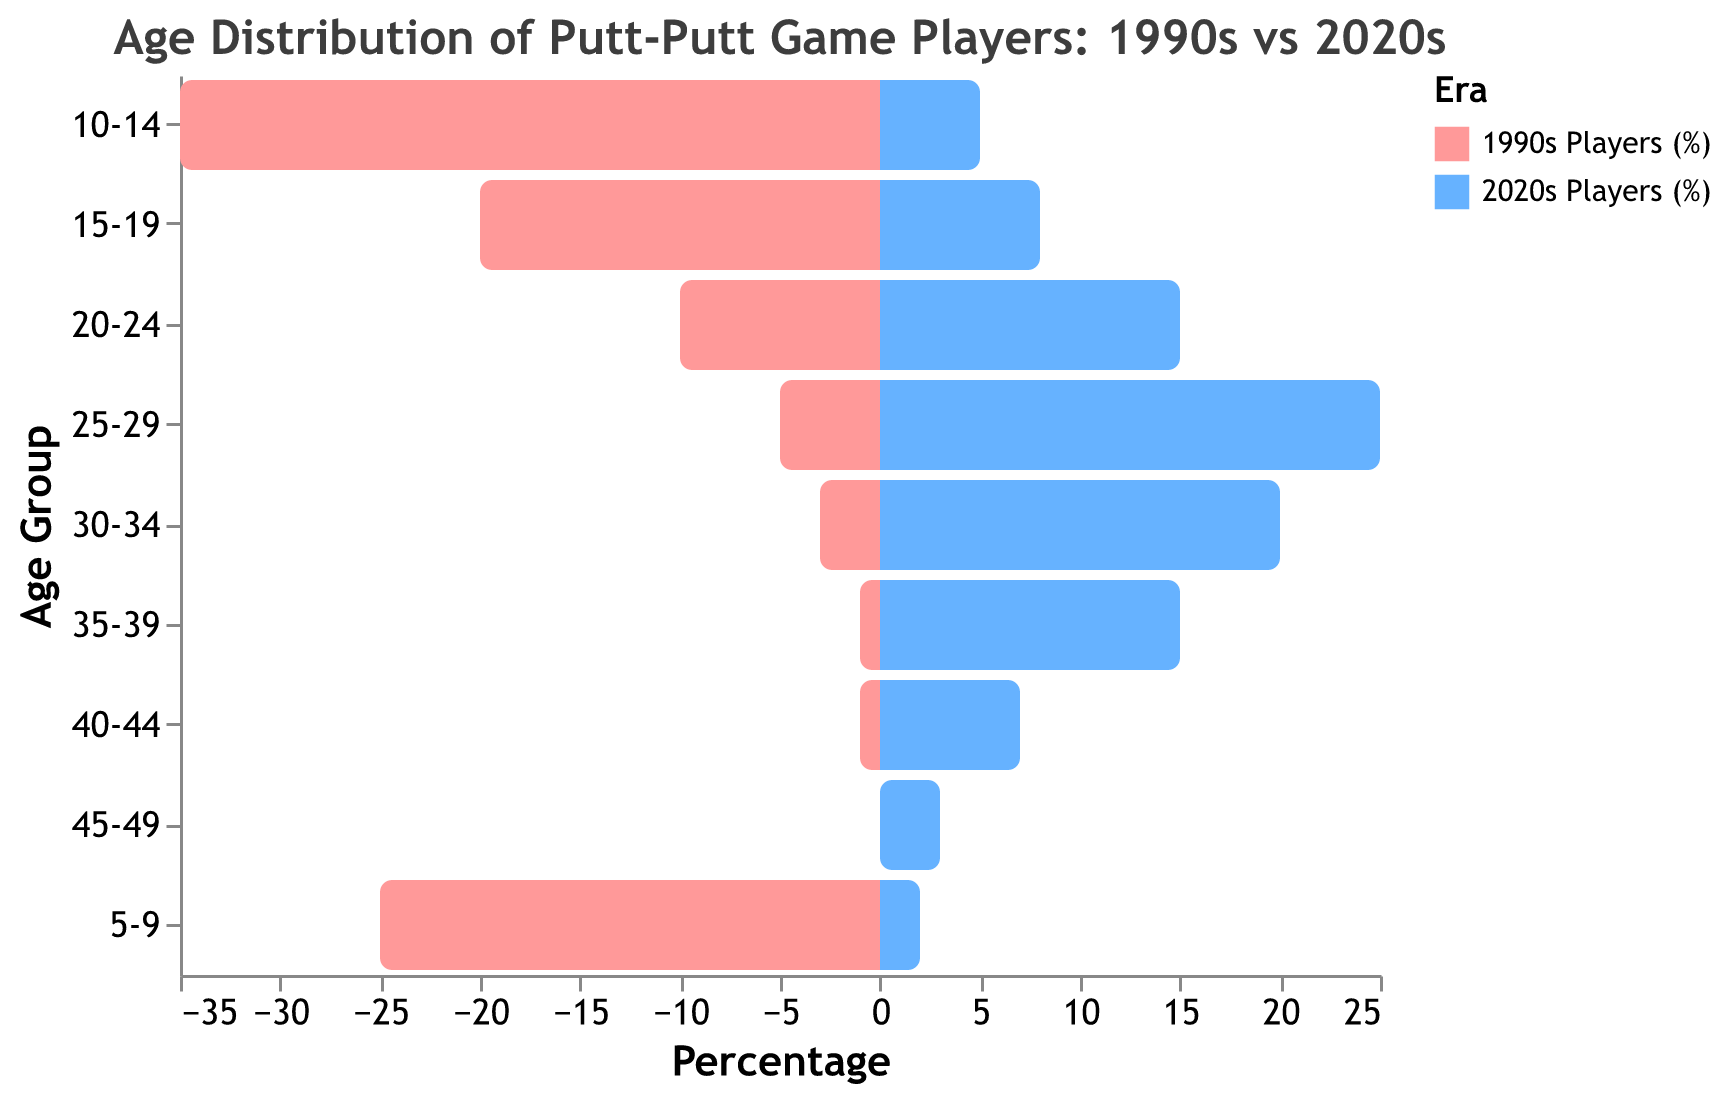What is the title of the figure? The title of the figure is usually found at the top and is meant to describe the content of the visual. Here, it is "Age Distribution of Putt-Putt Game Players: 1990s vs 2020s."
Answer: Age Distribution of Putt-Putt Game Players: 1990s vs 2020s What are the colors used to represent the different eras? The color legend in the figure shows which colors correspond to each era. The 1990s players are shown in pink, and the 2020s players are shown in blue.
Answer: Pink for 1990s, Blue for 2020s Which age group had the highest percentage of players in both eras? By observing the bars on the graph, you can see which age group has the longest bar for each era. For the 1990s, it's the 10-14 age group, and for the 2020s, it's the 25-29 age group.
Answer: 10-14 for the 1990s, 25-29 for the 2020s What percentage of players were in the 30-34 age group in the 2020s? To answer this, check the bar corresponding to the 30-34 age group and look at the value for the 2020s players. The tooltip or axis will indicate this value directly.
Answer: 20% Which age group shows the largest increase in player percentage from the 1990s to the 2020s? To find the largest increase, subtract the 1990s percentage from the 2020s percentage for each age group and find the largest value. The 25-29 age group increases from 5% to 25%, which is a 20% increase.
Answer: 25-29 age group How does the percentage of players aged 15-19 compare between the 1990s and the 2020s? Observe the bars for the 15-19 age group in both eras. The 1990s have 20%, while the 2020s have 8%.
Answer: 1990s: 20%, 2020s: 8% What is the combined percentage of players aged 20-24 and 25-29 in the 2020s? Add the percentages of the 20-24 and 25-29 age groups from the 2020s era. 15% + 25% = 40%.
Answer: 40% For which age groups did the percentage of players decrease from the 1990s to the 2020s? Compare the values for each age group between the two eras and see where the percentage has decreased. The groups 5-9, 10-14, and 15-19 all saw decreases.
Answer: 5-9, 10-14, 15-19 What is the total percentage of players aged 5-9, 10-14, and 15-19 during the 1990s? Sum the percentages of the 5-9, 10-14, and 15-19 age groups for the 1990s: 25% + 35% + 20% = 80%.
Answer: 80% 